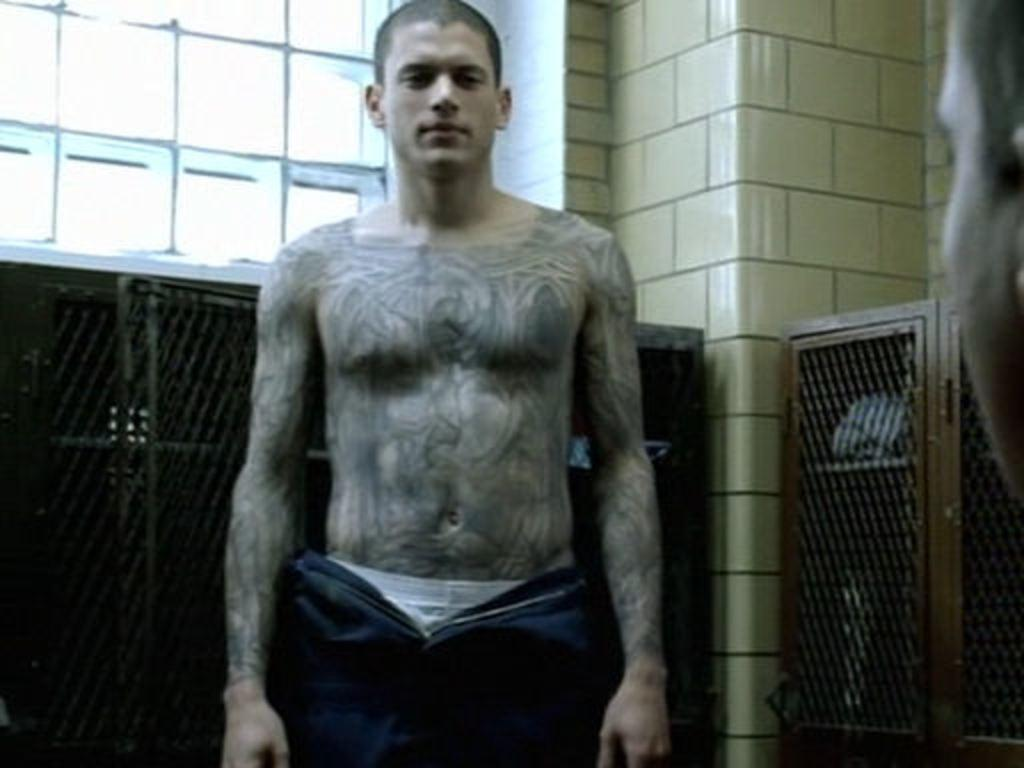What is the main subject of the image? There is a man standing in the image. What can be seen near the man? There are cupboards near the man. What is visible in the background of the image? There are windows and a wall in the background of the image. Where is the face of a person located in the image? The face of a person is on the left side of the image. What type of wilderness can be seen through the windows in the image? There is no wilderness visible through the windows in the image; only the wall can be seen in the background. How many birds are in the flock that is flying near the man in the image? There are no birds or flocks present in the image; it only features a man, cupboards, windows, a wall, and a face of a person. 